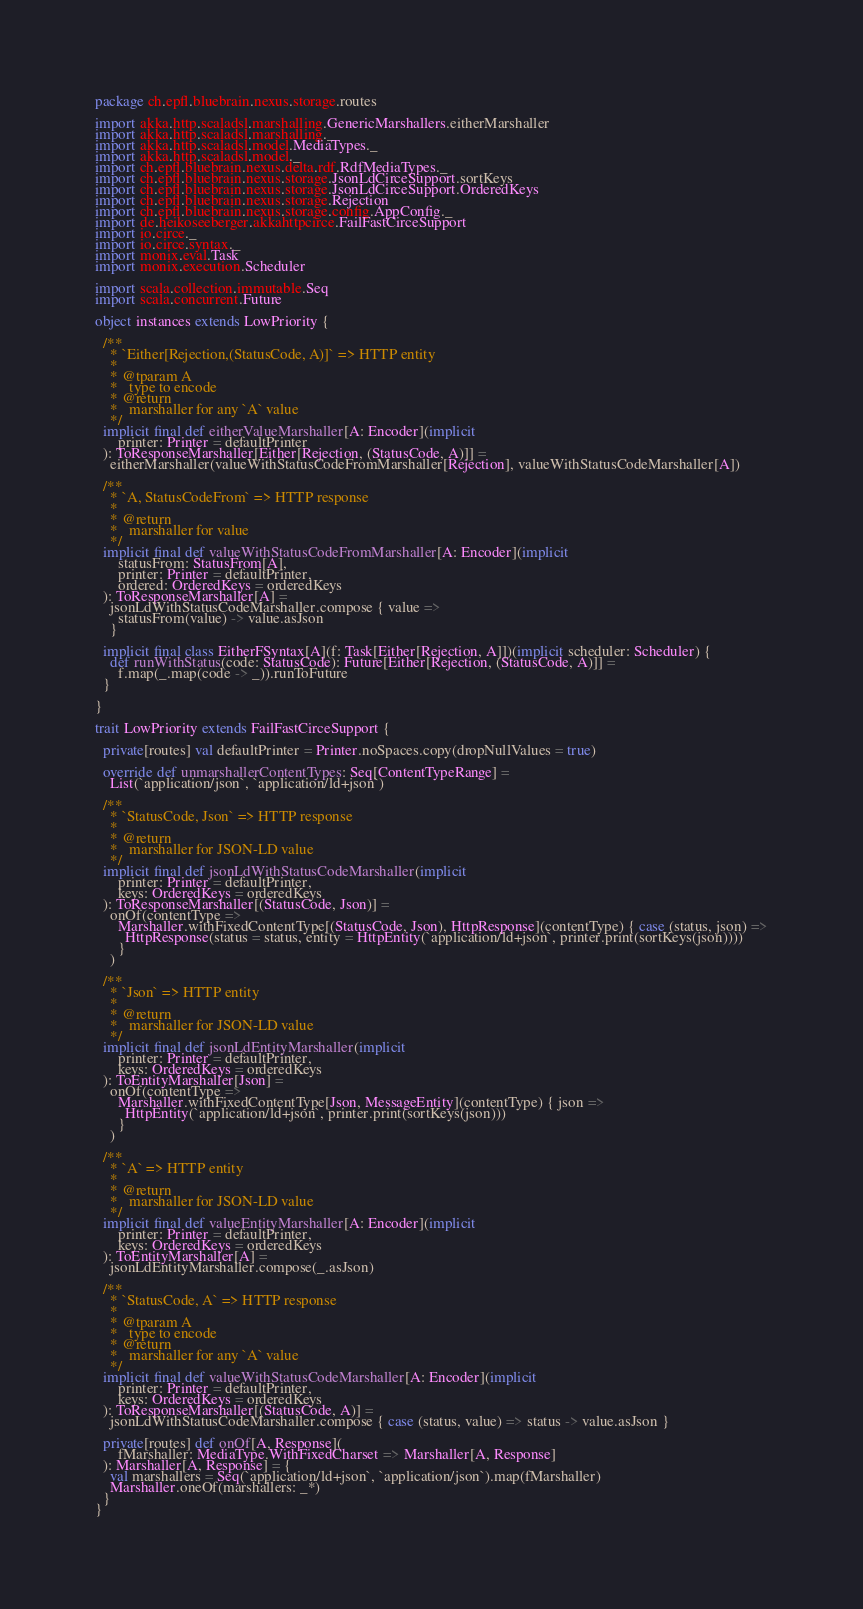Convert code to text. <code><loc_0><loc_0><loc_500><loc_500><_Scala_>package ch.epfl.bluebrain.nexus.storage.routes

import akka.http.scaladsl.marshalling.GenericMarshallers.eitherMarshaller
import akka.http.scaladsl.marshalling._
import akka.http.scaladsl.model.MediaTypes._
import akka.http.scaladsl.model._
import ch.epfl.bluebrain.nexus.delta.rdf.RdfMediaTypes._
import ch.epfl.bluebrain.nexus.storage.JsonLdCirceSupport.sortKeys
import ch.epfl.bluebrain.nexus.storage.JsonLdCirceSupport.OrderedKeys
import ch.epfl.bluebrain.nexus.storage.Rejection
import ch.epfl.bluebrain.nexus.storage.config.AppConfig._
import de.heikoseeberger.akkahttpcirce.FailFastCirceSupport
import io.circe._
import io.circe.syntax._
import monix.eval.Task
import monix.execution.Scheduler

import scala.collection.immutable.Seq
import scala.concurrent.Future

object instances extends LowPriority {

  /**
    * `Either[Rejection,(StatusCode, A)]` => HTTP entity
    *
    * @tparam A
    *   type to encode
    * @return
    *   marshaller for any `A` value
    */
  implicit final def eitherValueMarshaller[A: Encoder](implicit
      printer: Printer = defaultPrinter
  ): ToResponseMarshaller[Either[Rejection, (StatusCode, A)]] =
    eitherMarshaller(valueWithStatusCodeFromMarshaller[Rejection], valueWithStatusCodeMarshaller[A])

  /**
    * `A, StatusCodeFrom` => HTTP response
    *
    * @return
    *   marshaller for value
    */
  implicit final def valueWithStatusCodeFromMarshaller[A: Encoder](implicit
      statusFrom: StatusFrom[A],
      printer: Printer = defaultPrinter,
      ordered: OrderedKeys = orderedKeys
  ): ToResponseMarshaller[A] =
    jsonLdWithStatusCodeMarshaller.compose { value =>
      statusFrom(value) -> value.asJson
    }

  implicit final class EitherFSyntax[A](f: Task[Either[Rejection, A]])(implicit scheduler: Scheduler) {
    def runWithStatus(code: StatusCode): Future[Either[Rejection, (StatusCode, A)]] =
      f.map(_.map(code -> _)).runToFuture
  }

}

trait LowPriority extends FailFastCirceSupport {

  private[routes] val defaultPrinter = Printer.noSpaces.copy(dropNullValues = true)

  override def unmarshallerContentTypes: Seq[ContentTypeRange] =
    List(`application/json`, `application/ld+json`)

  /**
    * `StatusCode, Json` => HTTP response
    *
    * @return
    *   marshaller for JSON-LD value
    */
  implicit final def jsonLdWithStatusCodeMarshaller(implicit
      printer: Printer = defaultPrinter,
      keys: OrderedKeys = orderedKeys
  ): ToResponseMarshaller[(StatusCode, Json)] =
    onOf(contentType =>
      Marshaller.withFixedContentType[(StatusCode, Json), HttpResponse](contentType) { case (status, json) =>
        HttpResponse(status = status, entity = HttpEntity(`application/ld+json`, printer.print(sortKeys(json))))
      }
    )

  /**
    * `Json` => HTTP entity
    *
    * @return
    *   marshaller for JSON-LD value
    */
  implicit final def jsonLdEntityMarshaller(implicit
      printer: Printer = defaultPrinter,
      keys: OrderedKeys = orderedKeys
  ): ToEntityMarshaller[Json] =
    onOf(contentType =>
      Marshaller.withFixedContentType[Json, MessageEntity](contentType) { json =>
        HttpEntity(`application/ld+json`, printer.print(sortKeys(json)))
      }
    )

  /**
    * `A` => HTTP entity
    *
    * @return
    *   marshaller for JSON-LD value
    */
  implicit final def valueEntityMarshaller[A: Encoder](implicit
      printer: Printer = defaultPrinter,
      keys: OrderedKeys = orderedKeys
  ): ToEntityMarshaller[A] =
    jsonLdEntityMarshaller.compose(_.asJson)

  /**
    * `StatusCode, A` => HTTP response
    *
    * @tparam A
    *   type to encode
    * @return
    *   marshaller for any `A` value
    */
  implicit final def valueWithStatusCodeMarshaller[A: Encoder](implicit
      printer: Printer = defaultPrinter,
      keys: OrderedKeys = orderedKeys
  ): ToResponseMarshaller[(StatusCode, A)] =
    jsonLdWithStatusCodeMarshaller.compose { case (status, value) => status -> value.asJson }

  private[routes] def onOf[A, Response](
      fMarshaller: MediaType.WithFixedCharset => Marshaller[A, Response]
  ): Marshaller[A, Response] = {
    val marshallers = Seq(`application/ld+json`, `application/json`).map(fMarshaller)
    Marshaller.oneOf(marshallers: _*)
  }
}
</code> 